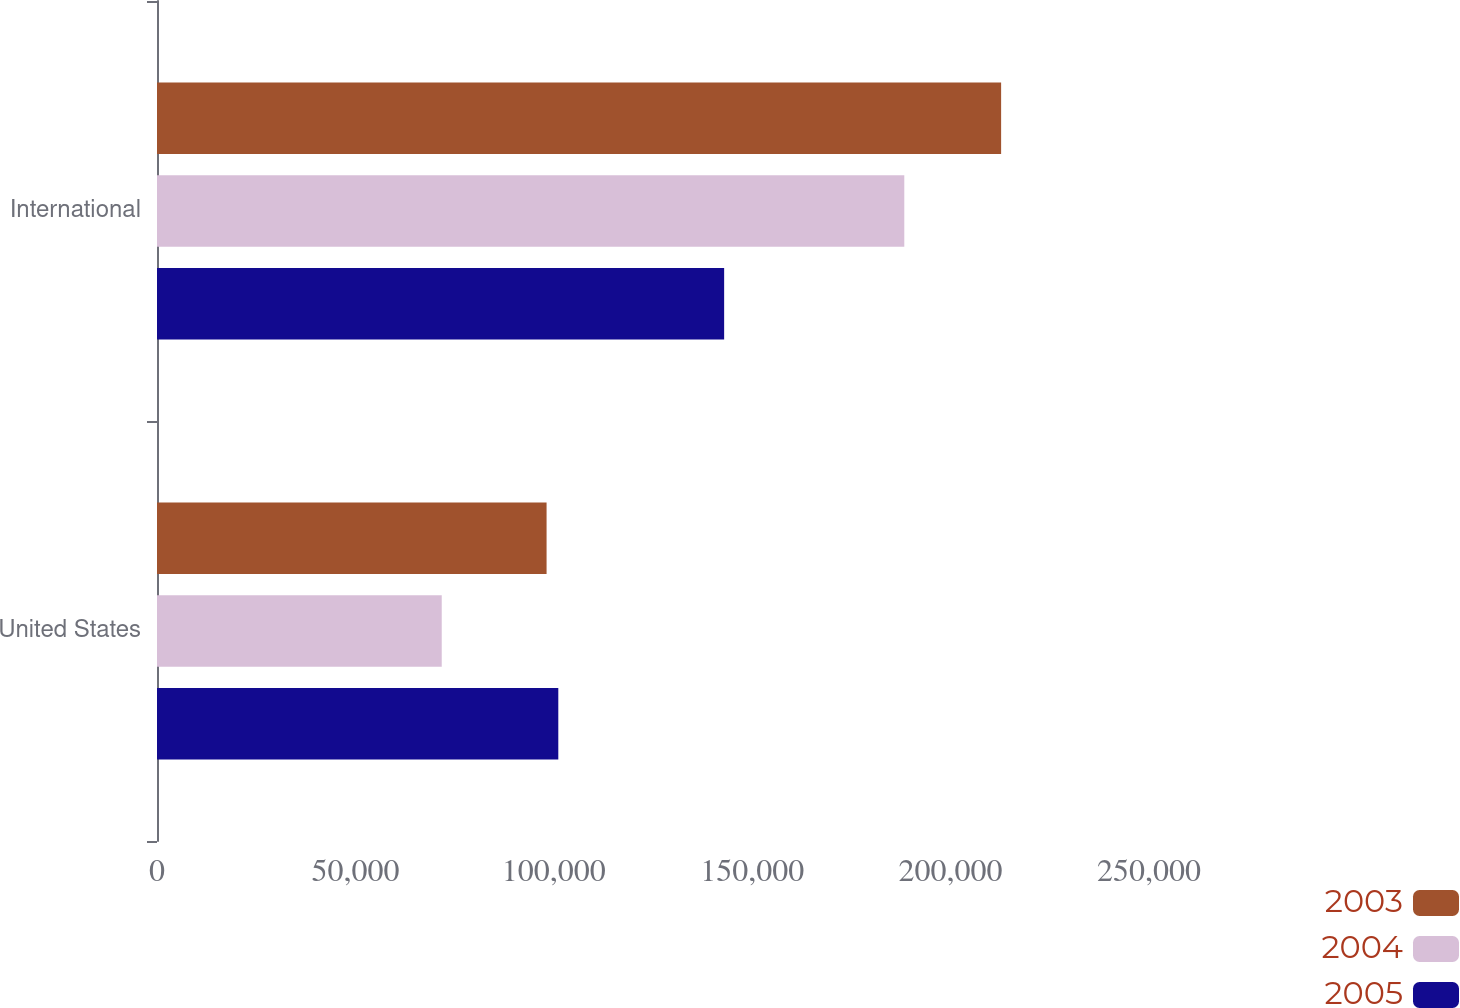<chart> <loc_0><loc_0><loc_500><loc_500><stacked_bar_chart><ecel><fcel>United States<fcel>International<nl><fcel>2003<fcel>98180<fcel>212733<nl><fcel>2004<fcel>71759<fcel>188329<nl><fcel>2005<fcel>101135<fcel>142929<nl></chart> 